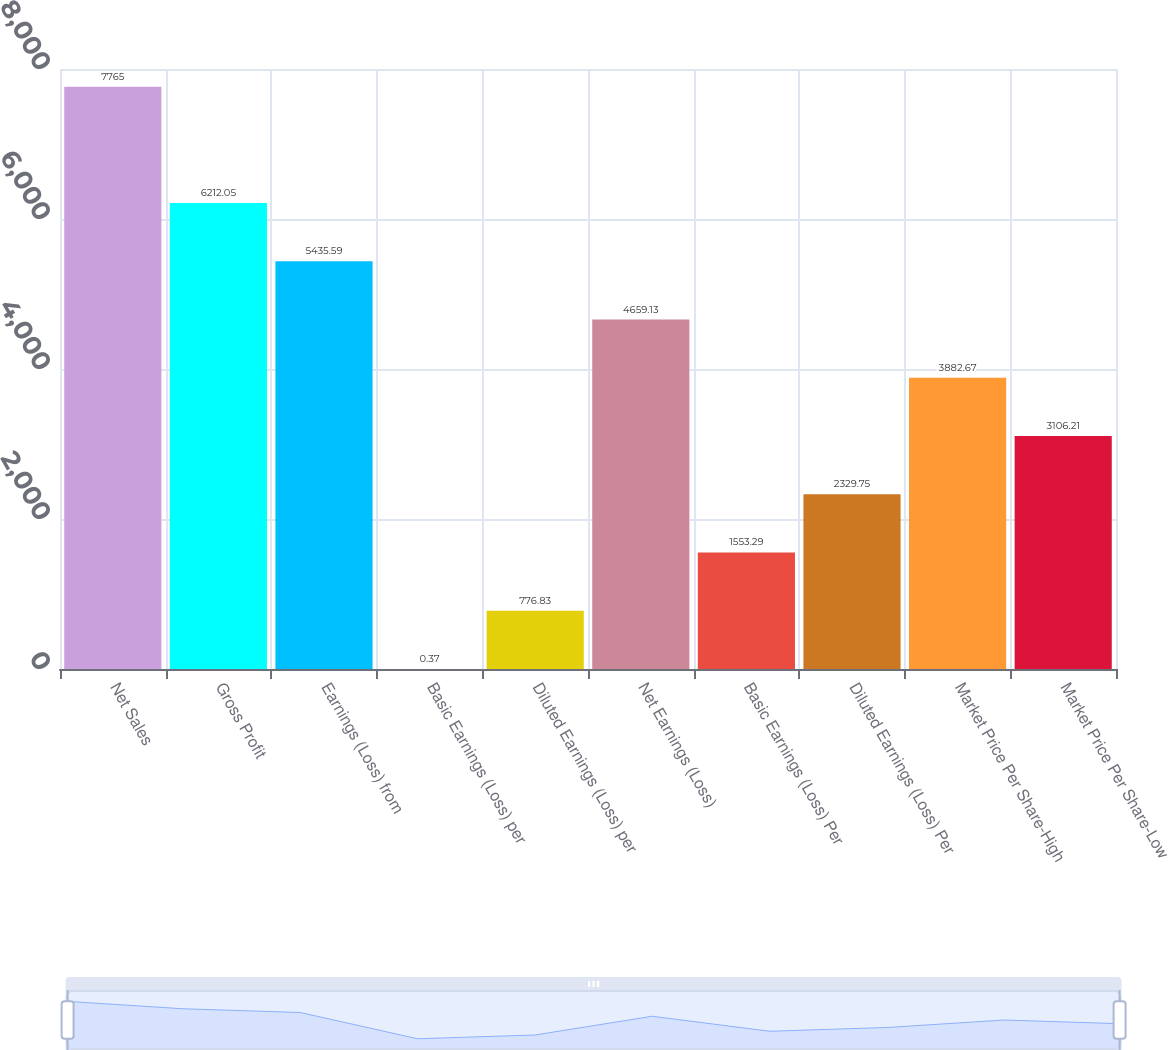<chart> <loc_0><loc_0><loc_500><loc_500><bar_chart><fcel>Net Sales<fcel>Gross Profit<fcel>Earnings (Loss) from<fcel>Basic Earnings (Loss) per<fcel>Diluted Earnings (Loss) per<fcel>Net Earnings (Loss)<fcel>Basic Earnings (Loss) Per<fcel>Diluted Earnings (Loss) Per<fcel>Market Price Per Share-High<fcel>Market Price Per Share-Low<nl><fcel>7765<fcel>6212.05<fcel>5435.59<fcel>0.37<fcel>776.83<fcel>4659.13<fcel>1553.29<fcel>2329.75<fcel>3882.67<fcel>3106.21<nl></chart> 